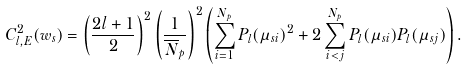Convert formula to latex. <formula><loc_0><loc_0><loc_500><loc_500>C _ { l , E } ^ { 2 } ( w _ { s } ) = \left ( \frac { 2 l + 1 } { 2 } \right ) ^ { 2 } \left ( \frac { 1 } { \overline { N } _ { p } } \right ) ^ { 2 } \left ( \sum _ { i = 1 } ^ { N _ { p } } P _ { l } ( \mu _ { s i } ) ^ { 2 } + 2 \sum _ { i < j } ^ { N _ { p } } P _ { l } ( \mu _ { s i } ) P _ { l } ( \mu _ { s j } ) \right ) .</formula> 